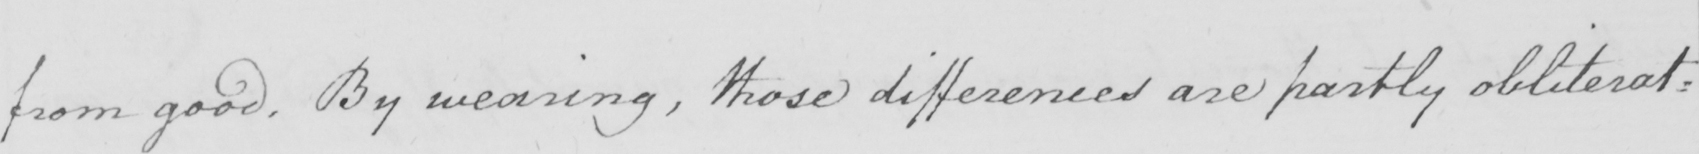What is written in this line of handwriting? from good . By wearing , those differences are partly obliterat= 